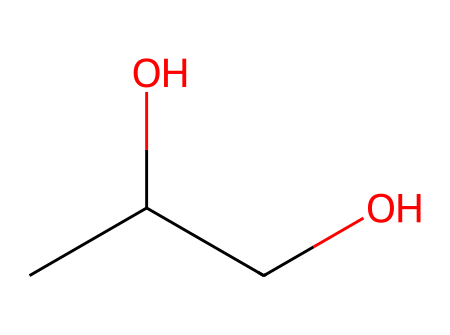what is the chemical name of the compound represented? The SMILES notation CC(O)CO corresponds to the structure of propylene glycol, which has a hydroxyl (-OH) group and is known for its moisture-retaining properties.
Answer: propylene glycol how many carbon atoms are in this molecule? From the SMILES representation CC(O)CO, there are two 'C' symbols showing that there are three carbon atoms in total.
Answer: 3 how many hydroxyl (–OH) groups are present in this compound? The SMILES shows an 'O' connected to two different carbon atoms, indicating there are two hydroxyl groups in the structure.
Answer: 2 what type of functional group does propylene glycol contain, based on its structure? The presence of the hydroxyl (-OH) groups in the structure indicates that this molecule is classified as an alcohol due to its functional groups.
Answer: alcohol is propylene glycol hydrophilic or hydrophobic? The presence of multiple hydroxyl groups in the structure is characteristic of hydrophilic substances, thus making propylene glycol hydrophilic.
Answer: hydrophilic what is the role of propylene glycol in confections? As a moisture-retaining agent, propylene glycol helps maintain the softness and freshness of confections by preventing them from drying out.
Answer: moisture-retaining agent how many total atoms are in the molecular structure of propylene glycol? The structure has 3 carbon atoms, 8 hydrogen atoms, and 2 oxygen atoms adding up to a total of 13 atoms in the molecule.
Answer: 13 